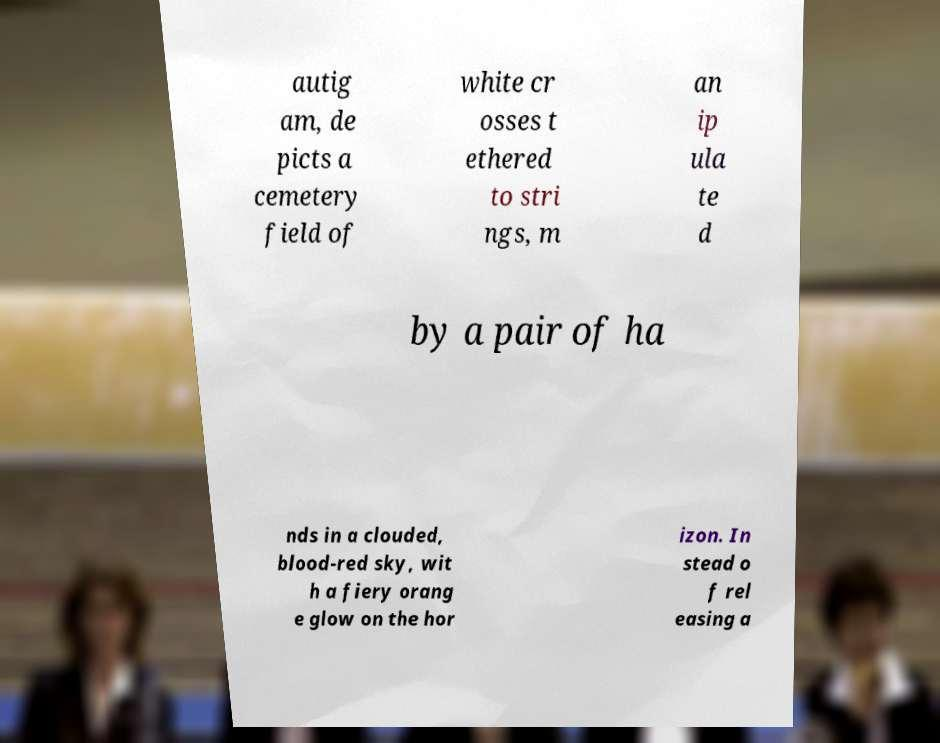What messages or text are displayed in this image? I need them in a readable, typed format. autig am, de picts a cemetery field of white cr osses t ethered to stri ngs, m an ip ula te d by a pair of ha nds in a clouded, blood-red sky, wit h a fiery orang e glow on the hor izon. In stead o f rel easing a 